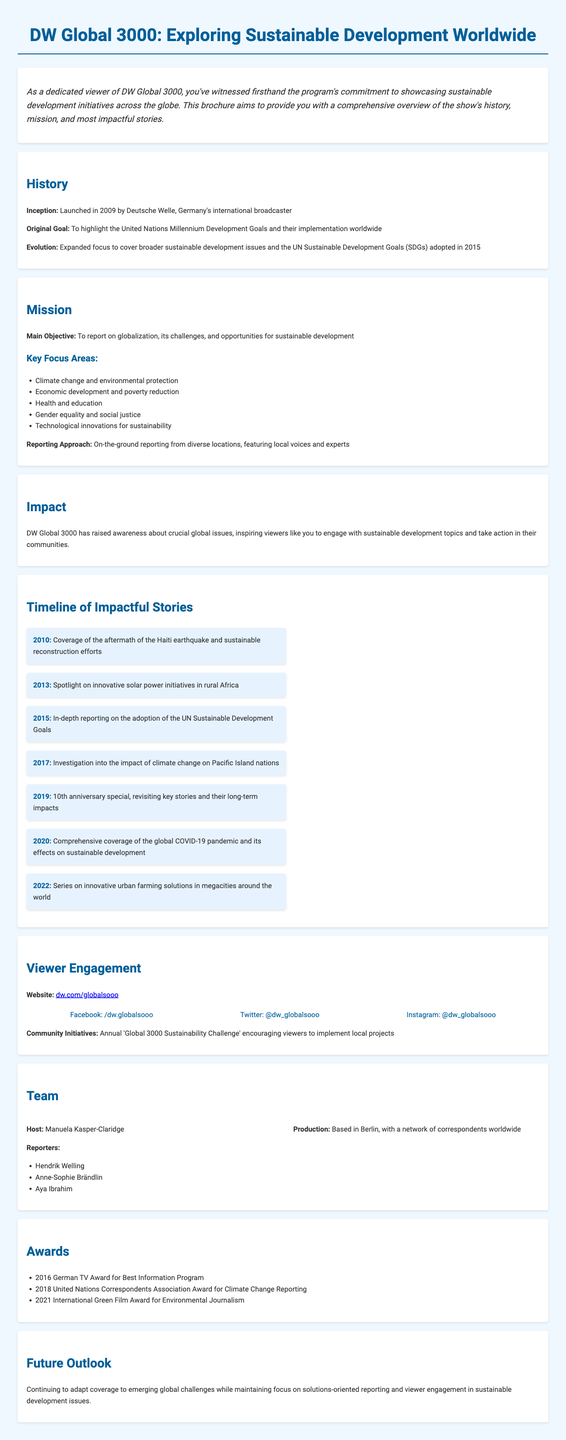What year was DW Global 3000 launched? The inception date of DW Global 3000 is mentioned as 2009 in the document.
Answer: 2009 What is the main objective of DW Global 3000? The main objective is described in the mission section of the document as reporting on globalization, its challenges, and opportunities for sustainable development.
Answer: To report on globalization, its challenges, and opportunities for sustainable development What significant reporting occurred in 2015? The timeline includes in-depth reporting on the adoption of the UN Sustainable Development Goals in 2015.
Answer: Adoption of the UN Sustainable Development Goals Who hosts DW Global 3000? The team section of the document names Manuela Kasper-Claridge as the host.
Answer: Manuela Kasper-Claridge What award did DW Global 3000 win in 2016? The awards section lists the 2016 German TV Award for Best Information Program as one of the accolades received.
Answer: German TV Award for Best Information Program How many focus areas are mentioned in the mission section? The mission section highlights five key focus areas related to sustainable development topics.
Answer: Five What community initiative does DW Global 3000 encourage? The viewer engagement section describes the annual 'Global 3000 Sustainability Challenge' as a community initiative.
Answer: Global 3000 Sustainability Challenge What is the production base of DW Global 3000's team? The team section mentions that the production is based in Berlin.
Answer: Berlin 